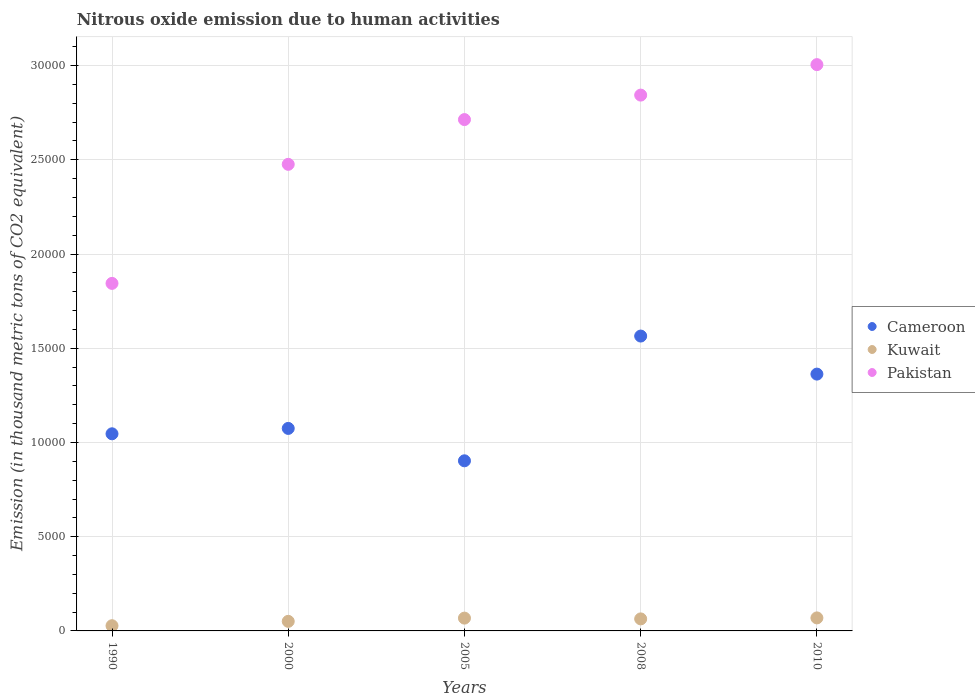Is the number of dotlines equal to the number of legend labels?
Offer a very short reply. Yes. What is the amount of nitrous oxide emitted in Kuwait in 2000?
Offer a terse response. 507.6. Across all years, what is the maximum amount of nitrous oxide emitted in Cameroon?
Offer a terse response. 1.56e+04. Across all years, what is the minimum amount of nitrous oxide emitted in Pakistan?
Keep it short and to the point. 1.84e+04. In which year was the amount of nitrous oxide emitted in Kuwait maximum?
Give a very brief answer. 2010. What is the total amount of nitrous oxide emitted in Kuwait in the graph?
Ensure brevity in your answer.  2792.1. What is the difference between the amount of nitrous oxide emitted in Kuwait in 1990 and that in 2005?
Your answer should be compact. -403.4. What is the difference between the amount of nitrous oxide emitted in Kuwait in 1990 and the amount of nitrous oxide emitted in Pakistan in 2010?
Provide a succinct answer. -2.98e+04. What is the average amount of nitrous oxide emitted in Cameroon per year?
Offer a terse response. 1.19e+04. In the year 2008, what is the difference between the amount of nitrous oxide emitted in Cameroon and amount of nitrous oxide emitted in Kuwait?
Provide a succinct answer. 1.50e+04. What is the ratio of the amount of nitrous oxide emitted in Kuwait in 1990 to that in 2005?
Make the answer very short. 0.41. What is the difference between the highest and the lowest amount of nitrous oxide emitted in Pakistan?
Your answer should be very brief. 1.16e+04. Is the sum of the amount of nitrous oxide emitted in Pakistan in 2000 and 2010 greater than the maximum amount of nitrous oxide emitted in Cameroon across all years?
Provide a succinct answer. Yes. Does the amount of nitrous oxide emitted in Cameroon monotonically increase over the years?
Your answer should be compact. No. How many dotlines are there?
Ensure brevity in your answer.  3. Are the values on the major ticks of Y-axis written in scientific E-notation?
Keep it short and to the point. No. How many legend labels are there?
Give a very brief answer. 3. How are the legend labels stacked?
Provide a succinct answer. Vertical. What is the title of the graph?
Offer a terse response. Nitrous oxide emission due to human activities. Does "Latvia" appear as one of the legend labels in the graph?
Your answer should be compact. No. What is the label or title of the X-axis?
Keep it short and to the point. Years. What is the label or title of the Y-axis?
Your answer should be compact. Emission (in thousand metric tons of CO2 equivalent). What is the Emission (in thousand metric tons of CO2 equivalent) in Cameroon in 1990?
Provide a short and direct response. 1.05e+04. What is the Emission (in thousand metric tons of CO2 equivalent) in Kuwait in 1990?
Ensure brevity in your answer.  276.1. What is the Emission (in thousand metric tons of CO2 equivalent) in Pakistan in 1990?
Give a very brief answer. 1.84e+04. What is the Emission (in thousand metric tons of CO2 equivalent) of Cameroon in 2000?
Your answer should be compact. 1.07e+04. What is the Emission (in thousand metric tons of CO2 equivalent) in Kuwait in 2000?
Offer a very short reply. 507.6. What is the Emission (in thousand metric tons of CO2 equivalent) in Pakistan in 2000?
Your response must be concise. 2.48e+04. What is the Emission (in thousand metric tons of CO2 equivalent) in Cameroon in 2005?
Offer a very short reply. 9027.2. What is the Emission (in thousand metric tons of CO2 equivalent) of Kuwait in 2005?
Your answer should be compact. 679.5. What is the Emission (in thousand metric tons of CO2 equivalent) of Pakistan in 2005?
Make the answer very short. 2.71e+04. What is the Emission (in thousand metric tons of CO2 equivalent) in Cameroon in 2008?
Your answer should be compact. 1.56e+04. What is the Emission (in thousand metric tons of CO2 equivalent) in Kuwait in 2008?
Your response must be concise. 638.4. What is the Emission (in thousand metric tons of CO2 equivalent) of Pakistan in 2008?
Make the answer very short. 2.84e+04. What is the Emission (in thousand metric tons of CO2 equivalent) in Cameroon in 2010?
Offer a terse response. 1.36e+04. What is the Emission (in thousand metric tons of CO2 equivalent) of Kuwait in 2010?
Your response must be concise. 690.5. What is the Emission (in thousand metric tons of CO2 equivalent) of Pakistan in 2010?
Your answer should be very brief. 3.01e+04. Across all years, what is the maximum Emission (in thousand metric tons of CO2 equivalent) in Cameroon?
Your response must be concise. 1.56e+04. Across all years, what is the maximum Emission (in thousand metric tons of CO2 equivalent) in Kuwait?
Offer a very short reply. 690.5. Across all years, what is the maximum Emission (in thousand metric tons of CO2 equivalent) in Pakistan?
Your answer should be very brief. 3.01e+04. Across all years, what is the minimum Emission (in thousand metric tons of CO2 equivalent) in Cameroon?
Provide a succinct answer. 9027.2. Across all years, what is the minimum Emission (in thousand metric tons of CO2 equivalent) of Kuwait?
Offer a very short reply. 276.1. Across all years, what is the minimum Emission (in thousand metric tons of CO2 equivalent) in Pakistan?
Make the answer very short. 1.84e+04. What is the total Emission (in thousand metric tons of CO2 equivalent) of Cameroon in the graph?
Give a very brief answer. 5.95e+04. What is the total Emission (in thousand metric tons of CO2 equivalent) in Kuwait in the graph?
Provide a succinct answer. 2792.1. What is the total Emission (in thousand metric tons of CO2 equivalent) in Pakistan in the graph?
Your response must be concise. 1.29e+05. What is the difference between the Emission (in thousand metric tons of CO2 equivalent) in Cameroon in 1990 and that in 2000?
Provide a succinct answer. -285.5. What is the difference between the Emission (in thousand metric tons of CO2 equivalent) of Kuwait in 1990 and that in 2000?
Provide a succinct answer. -231.5. What is the difference between the Emission (in thousand metric tons of CO2 equivalent) in Pakistan in 1990 and that in 2000?
Your answer should be compact. -6318. What is the difference between the Emission (in thousand metric tons of CO2 equivalent) of Cameroon in 1990 and that in 2005?
Ensure brevity in your answer.  1433.1. What is the difference between the Emission (in thousand metric tons of CO2 equivalent) in Kuwait in 1990 and that in 2005?
Keep it short and to the point. -403.4. What is the difference between the Emission (in thousand metric tons of CO2 equivalent) of Pakistan in 1990 and that in 2005?
Keep it short and to the point. -8692.8. What is the difference between the Emission (in thousand metric tons of CO2 equivalent) of Cameroon in 1990 and that in 2008?
Offer a very short reply. -5186.4. What is the difference between the Emission (in thousand metric tons of CO2 equivalent) of Kuwait in 1990 and that in 2008?
Offer a very short reply. -362.3. What is the difference between the Emission (in thousand metric tons of CO2 equivalent) in Pakistan in 1990 and that in 2008?
Ensure brevity in your answer.  -9991.4. What is the difference between the Emission (in thousand metric tons of CO2 equivalent) in Cameroon in 1990 and that in 2010?
Offer a terse response. -3167.4. What is the difference between the Emission (in thousand metric tons of CO2 equivalent) of Kuwait in 1990 and that in 2010?
Give a very brief answer. -414.4. What is the difference between the Emission (in thousand metric tons of CO2 equivalent) in Pakistan in 1990 and that in 2010?
Provide a succinct answer. -1.16e+04. What is the difference between the Emission (in thousand metric tons of CO2 equivalent) in Cameroon in 2000 and that in 2005?
Provide a succinct answer. 1718.6. What is the difference between the Emission (in thousand metric tons of CO2 equivalent) of Kuwait in 2000 and that in 2005?
Your answer should be very brief. -171.9. What is the difference between the Emission (in thousand metric tons of CO2 equivalent) of Pakistan in 2000 and that in 2005?
Give a very brief answer. -2374.8. What is the difference between the Emission (in thousand metric tons of CO2 equivalent) in Cameroon in 2000 and that in 2008?
Your answer should be compact. -4900.9. What is the difference between the Emission (in thousand metric tons of CO2 equivalent) in Kuwait in 2000 and that in 2008?
Your answer should be compact. -130.8. What is the difference between the Emission (in thousand metric tons of CO2 equivalent) in Pakistan in 2000 and that in 2008?
Provide a succinct answer. -3673.4. What is the difference between the Emission (in thousand metric tons of CO2 equivalent) in Cameroon in 2000 and that in 2010?
Keep it short and to the point. -2881.9. What is the difference between the Emission (in thousand metric tons of CO2 equivalent) of Kuwait in 2000 and that in 2010?
Offer a very short reply. -182.9. What is the difference between the Emission (in thousand metric tons of CO2 equivalent) in Pakistan in 2000 and that in 2010?
Provide a short and direct response. -5290.5. What is the difference between the Emission (in thousand metric tons of CO2 equivalent) in Cameroon in 2005 and that in 2008?
Keep it short and to the point. -6619.5. What is the difference between the Emission (in thousand metric tons of CO2 equivalent) of Kuwait in 2005 and that in 2008?
Make the answer very short. 41.1. What is the difference between the Emission (in thousand metric tons of CO2 equivalent) of Pakistan in 2005 and that in 2008?
Keep it short and to the point. -1298.6. What is the difference between the Emission (in thousand metric tons of CO2 equivalent) in Cameroon in 2005 and that in 2010?
Your answer should be compact. -4600.5. What is the difference between the Emission (in thousand metric tons of CO2 equivalent) in Kuwait in 2005 and that in 2010?
Your answer should be compact. -11. What is the difference between the Emission (in thousand metric tons of CO2 equivalent) of Pakistan in 2005 and that in 2010?
Give a very brief answer. -2915.7. What is the difference between the Emission (in thousand metric tons of CO2 equivalent) of Cameroon in 2008 and that in 2010?
Keep it short and to the point. 2019. What is the difference between the Emission (in thousand metric tons of CO2 equivalent) of Kuwait in 2008 and that in 2010?
Your answer should be very brief. -52.1. What is the difference between the Emission (in thousand metric tons of CO2 equivalent) of Pakistan in 2008 and that in 2010?
Keep it short and to the point. -1617.1. What is the difference between the Emission (in thousand metric tons of CO2 equivalent) of Cameroon in 1990 and the Emission (in thousand metric tons of CO2 equivalent) of Kuwait in 2000?
Your answer should be compact. 9952.7. What is the difference between the Emission (in thousand metric tons of CO2 equivalent) of Cameroon in 1990 and the Emission (in thousand metric tons of CO2 equivalent) of Pakistan in 2000?
Offer a very short reply. -1.43e+04. What is the difference between the Emission (in thousand metric tons of CO2 equivalent) of Kuwait in 1990 and the Emission (in thousand metric tons of CO2 equivalent) of Pakistan in 2000?
Offer a terse response. -2.45e+04. What is the difference between the Emission (in thousand metric tons of CO2 equivalent) in Cameroon in 1990 and the Emission (in thousand metric tons of CO2 equivalent) in Kuwait in 2005?
Offer a terse response. 9780.8. What is the difference between the Emission (in thousand metric tons of CO2 equivalent) of Cameroon in 1990 and the Emission (in thousand metric tons of CO2 equivalent) of Pakistan in 2005?
Your answer should be very brief. -1.67e+04. What is the difference between the Emission (in thousand metric tons of CO2 equivalent) in Kuwait in 1990 and the Emission (in thousand metric tons of CO2 equivalent) in Pakistan in 2005?
Keep it short and to the point. -2.69e+04. What is the difference between the Emission (in thousand metric tons of CO2 equivalent) of Cameroon in 1990 and the Emission (in thousand metric tons of CO2 equivalent) of Kuwait in 2008?
Give a very brief answer. 9821.9. What is the difference between the Emission (in thousand metric tons of CO2 equivalent) of Cameroon in 1990 and the Emission (in thousand metric tons of CO2 equivalent) of Pakistan in 2008?
Give a very brief answer. -1.80e+04. What is the difference between the Emission (in thousand metric tons of CO2 equivalent) in Kuwait in 1990 and the Emission (in thousand metric tons of CO2 equivalent) in Pakistan in 2008?
Give a very brief answer. -2.82e+04. What is the difference between the Emission (in thousand metric tons of CO2 equivalent) of Cameroon in 1990 and the Emission (in thousand metric tons of CO2 equivalent) of Kuwait in 2010?
Provide a succinct answer. 9769.8. What is the difference between the Emission (in thousand metric tons of CO2 equivalent) in Cameroon in 1990 and the Emission (in thousand metric tons of CO2 equivalent) in Pakistan in 2010?
Offer a terse response. -1.96e+04. What is the difference between the Emission (in thousand metric tons of CO2 equivalent) in Kuwait in 1990 and the Emission (in thousand metric tons of CO2 equivalent) in Pakistan in 2010?
Keep it short and to the point. -2.98e+04. What is the difference between the Emission (in thousand metric tons of CO2 equivalent) in Cameroon in 2000 and the Emission (in thousand metric tons of CO2 equivalent) in Kuwait in 2005?
Give a very brief answer. 1.01e+04. What is the difference between the Emission (in thousand metric tons of CO2 equivalent) in Cameroon in 2000 and the Emission (in thousand metric tons of CO2 equivalent) in Pakistan in 2005?
Offer a terse response. -1.64e+04. What is the difference between the Emission (in thousand metric tons of CO2 equivalent) of Kuwait in 2000 and the Emission (in thousand metric tons of CO2 equivalent) of Pakistan in 2005?
Give a very brief answer. -2.66e+04. What is the difference between the Emission (in thousand metric tons of CO2 equivalent) of Cameroon in 2000 and the Emission (in thousand metric tons of CO2 equivalent) of Kuwait in 2008?
Offer a very short reply. 1.01e+04. What is the difference between the Emission (in thousand metric tons of CO2 equivalent) of Cameroon in 2000 and the Emission (in thousand metric tons of CO2 equivalent) of Pakistan in 2008?
Your response must be concise. -1.77e+04. What is the difference between the Emission (in thousand metric tons of CO2 equivalent) in Kuwait in 2000 and the Emission (in thousand metric tons of CO2 equivalent) in Pakistan in 2008?
Offer a terse response. -2.79e+04. What is the difference between the Emission (in thousand metric tons of CO2 equivalent) in Cameroon in 2000 and the Emission (in thousand metric tons of CO2 equivalent) in Kuwait in 2010?
Give a very brief answer. 1.01e+04. What is the difference between the Emission (in thousand metric tons of CO2 equivalent) in Cameroon in 2000 and the Emission (in thousand metric tons of CO2 equivalent) in Pakistan in 2010?
Give a very brief answer. -1.93e+04. What is the difference between the Emission (in thousand metric tons of CO2 equivalent) in Kuwait in 2000 and the Emission (in thousand metric tons of CO2 equivalent) in Pakistan in 2010?
Your answer should be very brief. -2.95e+04. What is the difference between the Emission (in thousand metric tons of CO2 equivalent) of Cameroon in 2005 and the Emission (in thousand metric tons of CO2 equivalent) of Kuwait in 2008?
Keep it short and to the point. 8388.8. What is the difference between the Emission (in thousand metric tons of CO2 equivalent) of Cameroon in 2005 and the Emission (in thousand metric tons of CO2 equivalent) of Pakistan in 2008?
Provide a succinct answer. -1.94e+04. What is the difference between the Emission (in thousand metric tons of CO2 equivalent) of Kuwait in 2005 and the Emission (in thousand metric tons of CO2 equivalent) of Pakistan in 2008?
Offer a terse response. -2.78e+04. What is the difference between the Emission (in thousand metric tons of CO2 equivalent) of Cameroon in 2005 and the Emission (in thousand metric tons of CO2 equivalent) of Kuwait in 2010?
Your answer should be compact. 8336.7. What is the difference between the Emission (in thousand metric tons of CO2 equivalent) of Cameroon in 2005 and the Emission (in thousand metric tons of CO2 equivalent) of Pakistan in 2010?
Your answer should be compact. -2.10e+04. What is the difference between the Emission (in thousand metric tons of CO2 equivalent) in Kuwait in 2005 and the Emission (in thousand metric tons of CO2 equivalent) in Pakistan in 2010?
Make the answer very short. -2.94e+04. What is the difference between the Emission (in thousand metric tons of CO2 equivalent) of Cameroon in 2008 and the Emission (in thousand metric tons of CO2 equivalent) of Kuwait in 2010?
Provide a short and direct response. 1.50e+04. What is the difference between the Emission (in thousand metric tons of CO2 equivalent) in Cameroon in 2008 and the Emission (in thousand metric tons of CO2 equivalent) in Pakistan in 2010?
Provide a short and direct response. -1.44e+04. What is the difference between the Emission (in thousand metric tons of CO2 equivalent) in Kuwait in 2008 and the Emission (in thousand metric tons of CO2 equivalent) in Pakistan in 2010?
Your answer should be very brief. -2.94e+04. What is the average Emission (in thousand metric tons of CO2 equivalent) in Cameroon per year?
Provide a short and direct response. 1.19e+04. What is the average Emission (in thousand metric tons of CO2 equivalent) of Kuwait per year?
Give a very brief answer. 558.42. What is the average Emission (in thousand metric tons of CO2 equivalent) of Pakistan per year?
Provide a succinct answer. 2.58e+04. In the year 1990, what is the difference between the Emission (in thousand metric tons of CO2 equivalent) in Cameroon and Emission (in thousand metric tons of CO2 equivalent) in Kuwait?
Make the answer very short. 1.02e+04. In the year 1990, what is the difference between the Emission (in thousand metric tons of CO2 equivalent) in Cameroon and Emission (in thousand metric tons of CO2 equivalent) in Pakistan?
Provide a succinct answer. -7981.4. In the year 1990, what is the difference between the Emission (in thousand metric tons of CO2 equivalent) of Kuwait and Emission (in thousand metric tons of CO2 equivalent) of Pakistan?
Your answer should be very brief. -1.82e+04. In the year 2000, what is the difference between the Emission (in thousand metric tons of CO2 equivalent) of Cameroon and Emission (in thousand metric tons of CO2 equivalent) of Kuwait?
Ensure brevity in your answer.  1.02e+04. In the year 2000, what is the difference between the Emission (in thousand metric tons of CO2 equivalent) in Cameroon and Emission (in thousand metric tons of CO2 equivalent) in Pakistan?
Provide a succinct answer. -1.40e+04. In the year 2000, what is the difference between the Emission (in thousand metric tons of CO2 equivalent) of Kuwait and Emission (in thousand metric tons of CO2 equivalent) of Pakistan?
Provide a short and direct response. -2.43e+04. In the year 2005, what is the difference between the Emission (in thousand metric tons of CO2 equivalent) in Cameroon and Emission (in thousand metric tons of CO2 equivalent) in Kuwait?
Keep it short and to the point. 8347.7. In the year 2005, what is the difference between the Emission (in thousand metric tons of CO2 equivalent) of Cameroon and Emission (in thousand metric tons of CO2 equivalent) of Pakistan?
Give a very brief answer. -1.81e+04. In the year 2005, what is the difference between the Emission (in thousand metric tons of CO2 equivalent) of Kuwait and Emission (in thousand metric tons of CO2 equivalent) of Pakistan?
Make the answer very short. -2.65e+04. In the year 2008, what is the difference between the Emission (in thousand metric tons of CO2 equivalent) of Cameroon and Emission (in thousand metric tons of CO2 equivalent) of Kuwait?
Offer a terse response. 1.50e+04. In the year 2008, what is the difference between the Emission (in thousand metric tons of CO2 equivalent) of Cameroon and Emission (in thousand metric tons of CO2 equivalent) of Pakistan?
Your response must be concise. -1.28e+04. In the year 2008, what is the difference between the Emission (in thousand metric tons of CO2 equivalent) in Kuwait and Emission (in thousand metric tons of CO2 equivalent) in Pakistan?
Ensure brevity in your answer.  -2.78e+04. In the year 2010, what is the difference between the Emission (in thousand metric tons of CO2 equivalent) of Cameroon and Emission (in thousand metric tons of CO2 equivalent) of Kuwait?
Provide a short and direct response. 1.29e+04. In the year 2010, what is the difference between the Emission (in thousand metric tons of CO2 equivalent) in Cameroon and Emission (in thousand metric tons of CO2 equivalent) in Pakistan?
Provide a succinct answer. -1.64e+04. In the year 2010, what is the difference between the Emission (in thousand metric tons of CO2 equivalent) of Kuwait and Emission (in thousand metric tons of CO2 equivalent) of Pakistan?
Provide a succinct answer. -2.94e+04. What is the ratio of the Emission (in thousand metric tons of CO2 equivalent) of Cameroon in 1990 to that in 2000?
Provide a short and direct response. 0.97. What is the ratio of the Emission (in thousand metric tons of CO2 equivalent) in Kuwait in 1990 to that in 2000?
Ensure brevity in your answer.  0.54. What is the ratio of the Emission (in thousand metric tons of CO2 equivalent) of Pakistan in 1990 to that in 2000?
Your answer should be very brief. 0.74. What is the ratio of the Emission (in thousand metric tons of CO2 equivalent) in Cameroon in 1990 to that in 2005?
Give a very brief answer. 1.16. What is the ratio of the Emission (in thousand metric tons of CO2 equivalent) in Kuwait in 1990 to that in 2005?
Provide a succinct answer. 0.41. What is the ratio of the Emission (in thousand metric tons of CO2 equivalent) in Pakistan in 1990 to that in 2005?
Your answer should be very brief. 0.68. What is the ratio of the Emission (in thousand metric tons of CO2 equivalent) of Cameroon in 1990 to that in 2008?
Give a very brief answer. 0.67. What is the ratio of the Emission (in thousand metric tons of CO2 equivalent) in Kuwait in 1990 to that in 2008?
Ensure brevity in your answer.  0.43. What is the ratio of the Emission (in thousand metric tons of CO2 equivalent) in Pakistan in 1990 to that in 2008?
Your answer should be very brief. 0.65. What is the ratio of the Emission (in thousand metric tons of CO2 equivalent) of Cameroon in 1990 to that in 2010?
Give a very brief answer. 0.77. What is the ratio of the Emission (in thousand metric tons of CO2 equivalent) in Kuwait in 1990 to that in 2010?
Make the answer very short. 0.4. What is the ratio of the Emission (in thousand metric tons of CO2 equivalent) of Pakistan in 1990 to that in 2010?
Provide a short and direct response. 0.61. What is the ratio of the Emission (in thousand metric tons of CO2 equivalent) in Cameroon in 2000 to that in 2005?
Keep it short and to the point. 1.19. What is the ratio of the Emission (in thousand metric tons of CO2 equivalent) of Kuwait in 2000 to that in 2005?
Your response must be concise. 0.75. What is the ratio of the Emission (in thousand metric tons of CO2 equivalent) of Pakistan in 2000 to that in 2005?
Offer a very short reply. 0.91. What is the ratio of the Emission (in thousand metric tons of CO2 equivalent) in Cameroon in 2000 to that in 2008?
Keep it short and to the point. 0.69. What is the ratio of the Emission (in thousand metric tons of CO2 equivalent) in Kuwait in 2000 to that in 2008?
Offer a terse response. 0.8. What is the ratio of the Emission (in thousand metric tons of CO2 equivalent) of Pakistan in 2000 to that in 2008?
Offer a terse response. 0.87. What is the ratio of the Emission (in thousand metric tons of CO2 equivalent) of Cameroon in 2000 to that in 2010?
Ensure brevity in your answer.  0.79. What is the ratio of the Emission (in thousand metric tons of CO2 equivalent) in Kuwait in 2000 to that in 2010?
Offer a terse response. 0.74. What is the ratio of the Emission (in thousand metric tons of CO2 equivalent) of Pakistan in 2000 to that in 2010?
Make the answer very short. 0.82. What is the ratio of the Emission (in thousand metric tons of CO2 equivalent) of Cameroon in 2005 to that in 2008?
Provide a short and direct response. 0.58. What is the ratio of the Emission (in thousand metric tons of CO2 equivalent) in Kuwait in 2005 to that in 2008?
Give a very brief answer. 1.06. What is the ratio of the Emission (in thousand metric tons of CO2 equivalent) of Pakistan in 2005 to that in 2008?
Provide a succinct answer. 0.95. What is the ratio of the Emission (in thousand metric tons of CO2 equivalent) in Cameroon in 2005 to that in 2010?
Ensure brevity in your answer.  0.66. What is the ratio of the Emission (in thousand metric tons of CO2 equivalent) of Kuwait in 2005 to that in 2010?
Ensure brevity in your answer.  0.98. What is the ratio of the Emission (in thousand metric tons of CO2 equivalent) in Pakistan in 2005 to that in 2010?
Provide a short and direct response. 0.9. What is the ratio of the Emission (in thousand metric tons of CO2 equivalent) of Cameroon in 2008 to that in 2010?
Provide a succinct answer. 1.15. What is the ratio of the Emission (in thousand metric tons of CO2 equivalent) in Kuwait in 2008 to that in 2010?
Offer a very short reply. 0.92. What is the ratio of the Emission (in thousand metric tons of CO2 equivalent) in Pakistan in 2008 to that in 2010?
Offer a very short reply. 0.95. What is the difference between the highest and the second highest Emission (in thousand metric tons of CO2 equivalent) of Cameroon?
Provide a succinct answer. 2019. What is the difference between the highest and the second highest Emission (in thousand metric tons of CO2 equivalent) of Kuwait?
Ensure brevity in your answer.  11. What is the difference between the highest and the second highest Emission (in thousand metric tons of CO2 equivalent) of Pakistan?
Make the answer very short. 1617.1. What is the difference between the highest and the lowest Emission (in thousand metric tons of CO2 equivalent) in Cameroon?
Your answer should be compact. 6619.5. What is the difference between the highest and the lowest Emission (in thousand metric tons of CO2 equivalent) of Kuwait?
Provide a short and direct response. 414.4. What is the difference between the highest and the lowest Emission (in thousand metric tons of CO2 equivalent) in Pakistan?
Your response must be concise. 1.16e+04. 